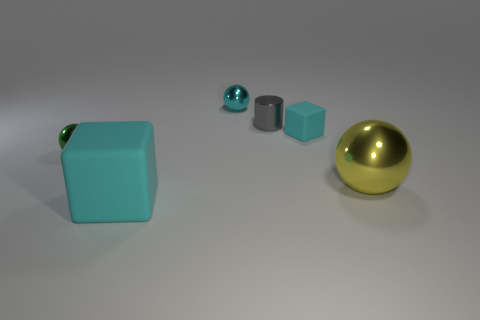There is a ball that is the same color as the small block; what is its size?
Offer a very short reply. Small. What number of other objects are the same color as the tiny metallic cylinder?
Provide a succinct answer. 0. Is the number of green spheres that are on the right side of the big matte thing less than the number of small cyan objects?
Your response must be concise. Yes. Is there a green object that has the same size as the metallic cylinder?
Offer a terse response. Yes. There is a tiny rubber block; is it the same color as the sphere behind the tiny green thing?
Offer a terse response. Yes. There is a tiny metal ball that is behind the green object; what number of big things are on the left side of it?
Your response must be concise. 1. There is a matte thing on the left side of the small metallic cylinder on the right side of the tiny cyan ball; what color is it?
Offer a very short reply. Cyan. What material is the tiny thing that is both in front of the small gray cylinder and to the right of the small green thing?
Ensure brevity in your answer.  Rubber. Are there any small cyan things that have the same shape as the yellow metal thing?
Make the answer very short. Yes. Does the thing that is in front of the large sphere have the same shape as the small gray metallic object?
Provide a short and direct response. No. 